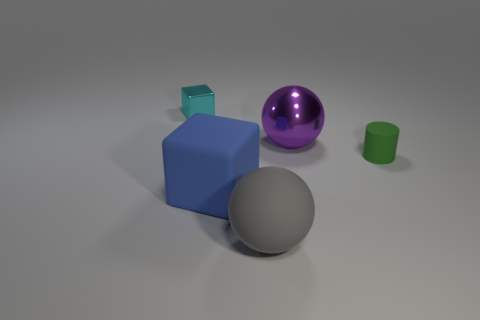There is a gray thing that is the same material as the small green object; what is its shape?
Your answer should be compact. Sphere. How many gray things are the same shape as the purple shiny object?
Keep it short and to the point. 1. What material is the small block?
Your answer should be very brief. Metal. How many spheres are either small matte things or large metallic things?
Offer a very short reply. 1. The metallic object in front of the small metal block is what color?
Provide a short and direct response. Purple. What number of blocks have the same size as the gray matte ball?
Make the answer very short. 1. There is a big object right of the large gray rubber ball; is it the same shape as the large object that is left of the large gray sphere?
Offer a terse response. No. What material is the big object that is behind the big rubber thing that is behind the big ball that is to the left of the big purple ball made of?
Give a very brief answer. Metal. What shape is the green thing that is the same size as the cyan metal thing?
Your answer should be compact. Cylinder. What is the size of the green cylinder?
Your response must be concise. Small. 